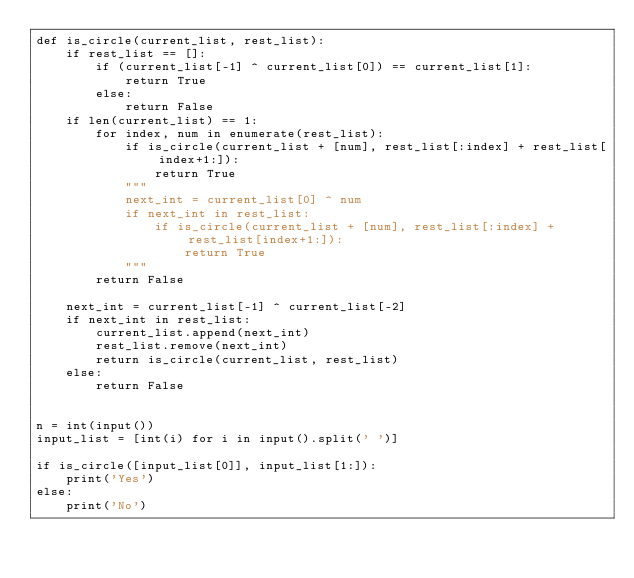Convert code to text. <code><loc_0><loc_0><loc_500><loc_500><_Python_>def is_circle(current_list, rest_list):
    if rest_list == []:
        if (current_list[-1] ^ current_list[0]) == current_list[1]:
            return True
        else:
            return False
    if len(current_list) == 1:
        for index, num in enumerate(rest_list):
            if is_circle(current_list + [num], rest_list[:index] + rest_list[index+1:]):
                return True
            """
            next_int = current_list[0] ^ num
            if next_int in rest_list:
                if is_circle(current_list + [num], rest_list[:index] + rest_list[index+1:]):
                    return True
            """
        return False

    next_int = current_list[-1] ^ current_list[-2]
    if next_int in rest_list:
        current_list.append(next_int)
        rest_list.remove(next_int)
        return is_circle(current_list, rest_list)
    else:
        return False
        

n = int(input())
input_list = [int(i) for i in input().split(' ')]

if is_circle([input_list[0]], input_list[1:]):
    print('Yes')
else:
    print('No')</code> 